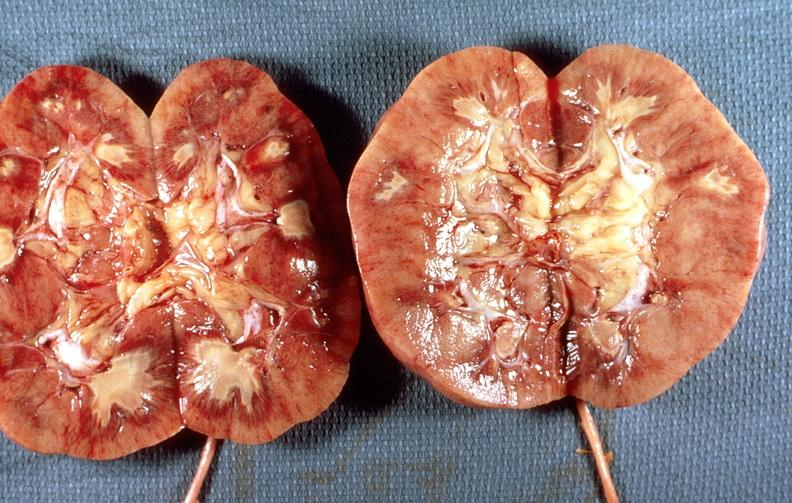what does this image show?
Answer the question using a single word or phrase. Renal papillary necrosis 